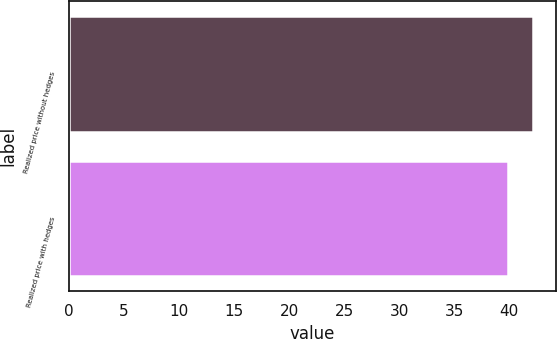Convert chart to OTSL. <chart><loc_0><loc_0><loc_500><loc_500><bar_chart><fcel>Realized price without hedges<fcel>Realized price with hedges<nl><fcel>42.18<fcel>39.89<nl></chart> 